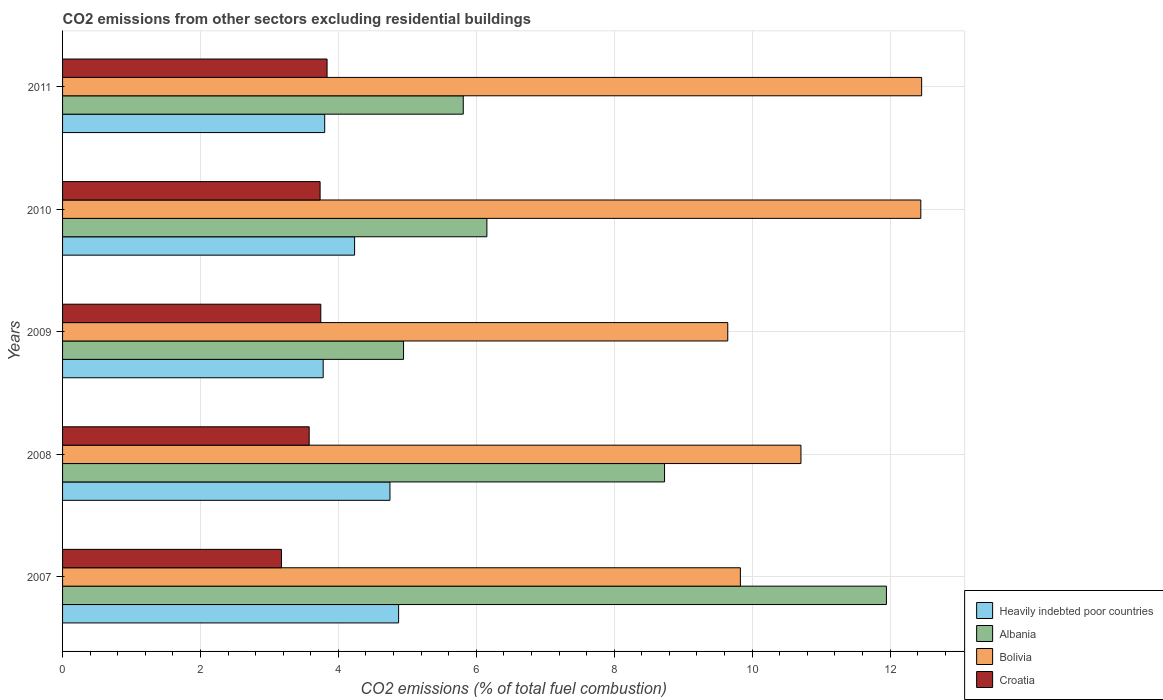How many different coloured bars are there?
Provide a short and direct response. 4. How many groups of bars are there?
Your answer should be very brief. 5. Are the number of bars on each tick of the Y-axis equal?
Ensure brevity in your answer.  Yes. How many bars are there on the 1st tick from the bottom?
Give a very brief answer. 4. What is the label of the 3rd group of bars from the top?
Make the answer very short. 2009. In how many cases, is the number of bars for a given year not equal to the number of legend labels?
Give a very brief answer. 0. What is the total CO2 emitted in Bolivia in 2007?
Make the answer very short. 9.83. Across all years, what is the maximum total CO2 emitted in Bolivia?
Your response must be concise. 12.46. Across all years, what is the minimum total CO2 emitted in Heavily indebted poor countries?
Provide a short and direct response. 3.78. In which year was the total CO2 emitted in Croatia maximum?
Your answer should be very brief. 2011. In which year was the total CO2 emitted in Croatia minimum?
Ensure brevity in your answer.  2007. What is the total total CO2 emitted in Bolivia in the graph?
Give a very brief answer. 55.09. What is the difference between the total CO2 emitted in Albania in 2007 and that in 2008?
Your answer should be very brief. 3.22. What is the difference between the total CO2 emitted in Bolivia in 2010 and the total CO2 emitted in Heavily indebted poor countries in 2008?
Make the answer very short. 7.7. What is the average total CO2 emitted in Croatia per year?
Your answer should be very brief. 3.61. In the year 2007, what is the difference between the total CO2 emitted in Albania and total CO2 emitted in Bolivia?
Your answer should be compact. 2.12. What is the ratio of the total CO2 emitted in Heavily indebted poor countries in 2010 to that in 2011?
Your answer should be compact. 1.11. Is the total CO2 emitted in Heavily indebted poor countries in 2008 less than that in 2011?
Keep it short and to the point. No. What is the difference between the highest and the second highest total CO2 emitted in Albania?
Your response must be concise. 3.22. What is the difference between the highest and the lowest total CO2 emitted in Croatia?
Your response must be concise. 0.66. Is the sum of the total CO2 emitted in Albania in 2008 and 2009 greater than the maximum total CO2 emitted in Croatia across all years?
Ensure brevity in your answer.  Yes. Is it the case that in every year, the sum of the total CO2 emitted in Albania and total CO2 emitted in Croatia is greater than the sum of total CO2 emitted in Bolivia and total CO2 emitted in Heavily indebted poor countries?
Make the answer very short. No. What does the 1st bar from the top in 2008 represents?
Provide a short and direct response. Croatia. What does the 4th bar from the bottom in 2010 represents?
Keep it short and to the point. Croatia. Does the graph contain grids?
Keep it short and to the point. Yes. How many legend labels are there?
Provide a succinct answer. 4. How are the legend labels stacked?
Give a very brief answer. Vertical. What is the title of the graph?
Give a very brief answer. CO2 emissions from other sectors excluding residential buildings. What is the label or title of the X-axis?
Ensure brevity in your answer.  CO2 emissions (% of total fuel combustion). What is the CO2 emissions (% of total fuel combustion) in Heavily indebted poor countries in 2007?
Offer a terse response. 4.87. What is the CO2 emissions (% of total fuel combustion) of Albania in 2007?
Make the answer very short. 11.95. What is the CO2 emissions (% of total fuel combustion) of Bolivia in 2007?
Keep it short and to the point. 9.83. What is the CO2 emissions (% of total fuel combustion) of Croatia in 2007?
Your answer should be compact. 3.17. What is the CO2 emissions (% of total fuel combustion) of Heavily indebted poor countries in 2008?
Offer a very short reply. 4.75. What is the CO2 emissions (% of total fuel combustion) in Albania in 2008?
Make the answer very short. 8.73. What is the CO2 emissions (% of total fuel combustion) of Bolivia in 2008?
Your answer should be very brief. 10.71. What is the CO2 emissions (% of total fuel combustion) in Croatia in 2008?
Offer a very short reply. 3.58. What is the CO2 emissions (% of total fuel combustion) in Heavily indebted poor countries in 2009?
Offer a very short reply. 3.78. What is the CO2 emissions (% of total fuel combustion) of Albania in 2009?
Provide a short and direct response. 4.95. What is the CO2 emissions (% of total fuel combustion) in Bolivia in 2009?
Offer a terse response. 9.65. What is the CO2 emissions (% of total fuel combustion) of Croatia in 2009?
Give a very brief answer. 3.74. What is the CO2 emissions (% of total fuel combustion) of Heavily indebted poor countries in 2010?
Give a very brief answer. 4.24. What is the CO2 emissions (% of total fuel combustion) in Albania in 2010?
Keep it short and to the point. 6.15. What is the CO2 emissions (% of total fuel combustion) in Bolivia in 2010?
Provide a short and direct response. 12.45. What is the CO2 emissions (% of total fuel combustion) of Croatia in 2010?
Give a very brief answer. 3.73. What is the CO2 emissions (% of total fuel combustion) of Heavily indebted poor countries in 2011?
Make the answer very short. 3.8. What is the CO2 emissions (% of total fuel combustion) of Albania in 2011?
Ensure brevity in your answer.  5.81. What is the CO2 emissions (% of total fuel combustion) in Bolivia in 2011?
Provide a short and direct response. 12.46. What is the CO2 emissions (% of total fuel combustion) of Croatia in 2011?
Keep it short and to the point. 3.84. Across all years, what is the maximum CO2 emissions (% of total fuel combustion) in Heavily indebted poor countries?
Make the answer very short. 4.87. Across all years, what is the maximum CO2 emissions (% of total fuel combustion) in Albania?
Your answer should be very brief. 11.95. Across all years, what is the maximum CO2 emissions (% of total fuel combustion) in Bolivia?
Your answer should be compact. 12.46. Across all years, what is the maximum CO2 emissions (% of total fuel combustion) in Croatia?
Offer a terse response. 3.84. Across all years, what is the minimum CO2 emissions (% of total fuel combustion) in Heavily indebted poor countries?
Your response must be concise. 3.78. Across all years, what is the minimum CO2 emissions (% of total fuel combustion) of Albania?
Offer a very short reply. 4.95. Across all years, what is the minimum CO2 emissions (% of total fuel combustion) in Bolivia?
Give a very brief answer. 9.65. Across all years, what is the minimum CO2 emissions (% of total fuel combustion) in Croatia?
Give a very brief answer. 3.17. What is the total CO2 emissions (% of total fuel combustion) of Heavily indebted poor countries in the graph?
Offer a terse response. 21.44. What is the total CO2 emissions (% of total fuel combustion) in Albania in the graph?
Your response must be concise. 37.59. What is the total CO2 emissions (% of total fuel combustion) of Bolivia in the graph?
Offer a very short reply. 55.09. What is the total CO2 emissions (% of total fuel combustion) in Croatia in the graph?
Make the answer very short. 18.07. What is the difference between the CO2 emissions (% of total fuel combustion) in Heavily indebted poor countries in 2007 and that in 2008?
Ensure brevity in your answer.  0.13. What is the difference between the CO2 emissions (% of total fuel combustion) of Albania in 2007 and that in 2008?
Provide a succinct answer. 3.22. What is the difference between the CO2 emissions (% of total fuel combustion) in Bolivia in 2007 and that in 2008?
Offer a very short reply. -0.88. What is the difference between the CO2 emissions (% of total fuel combustion) of Croatia in 2007 and that in 2008?
Offer a very short reply. -0.4. What is the difference between the CO2 emissions (% of total fuel combustion) in Heavily indebted poor countries in 2007 and that in 2009?
Offer a very short reply. 1.09. What is the difference between the CO2 emissions (% of total fuel combustion) of Albania in 2007 and that in 2009?
Ensure brevity in your answer.  7. What is the difference between the CO2 emissions (% of total fuel combustion) of Bolivia in 2007 and that in 2009?
Your answer should be compact. 0.18. What is the difference between the CO2 emissions (% of total fuel combustion) of Croatia in 2007 and that in 2009?
Your answer should be compact. -0.57. What is the difference between the CO2 emissions (% of total fuel combustion) in Heavily indebted poor countries in 2007 and that in 2010?
Make the answer very short. 0.64. What is the difference between the CO2 emissions (% of total fuel combustion) in Albania in 2007 and that in 2010?
Your answer should be very brief. 5.79. What is the difference between the CO2 emissions (% of total fuel combustion) of Bolivia in 2007 and that in 2010?
Give a very brief answer. -2.62. What is the difference between the CO2 emissions (% of total fuel combustion) in Croatia in 2007 and that in 2010?
Your response must be concise. -0.56. What is the difference between the CO2 emissions (% of total fuel combustion) in Heavily indebted poor countries in 2007 and that in 2011?
Provide a short and direct response. 1.07. What is the difference between the CO2 emissions (% of total fuel combustion) in Albania in 2007 and that in 2011?
Offer a very short reply. 6.14. What is the difference between the CO2 emissions (% of total fuel combustion) of Bolivia in 2007 and that in 2011?
Offer a terse response. -2.63. What is the difference between the CO2 emissions (% of total fuel combustion) in Croatia in 2007 and that in 2011?
Make the answer very short. -0.66. What is the difference between the CO2 emissions (% of total fuel combustion) of Heavily indebted poor countries in 2008 and that in 2009?
Your answer should be very brief. 0.97. What is the difference between the CO2 emissions (% of total fuel combustion) in Albania in 2008 and that in 2009?
Offer a terse response. 3.79. What is the difference between the CO2 emissions (% of total fuel combustion) of Bolivia in 2008 and that in 2009?
Keep it short and to the point. 1.06. What is the difference between the CO2 emissions (% of total fuel combustion) in Croatia in 2008 and that in 2009?
Offer a terse response. -0.17. What is the difference between the CO2 emissions (% of total fuel combustion) in Heavily indebted poor countries in 2008 and that in 2010?
Your answer should be very brief. 0.51. What is the difference between the CO2 emissions (% of total fuel combustion) in Albania in 2008 and that in 2010?
Ensure brevity in your answer.  2.58. What is the difference between the CO2 emissions (% of total fuel combustion) of Bolivia in 2008 and that in 2010?
Your answer should be very brief. -1.74. What is the difference between the CO2 emissions (% of total fuel combustion) in Croatia in 2008 and that in 2010?
Provide a short and direct response. -0.16. What is the difference between the CO2 emissions (% of total fuel combustion) in Heavily indebted poor countries in 2008 and that in 2011?
Offer a very short reply. 0.95. What is the difference between the CO2 emissions (% of total fuel combustion) in Albania in 2008 and that in 2011?
Your answer should be very brief. 2.92. What is the difference between the CO2 emissions (% of total fuel combustion) of Bolivia in 2008 and that in 2011?
Make the answer very short. -1.75. What is the difference between the CO2 emissions (% of total fuel combustion) of Croatia in 2008 and that in 2011?
Offer a very short reply. -0.26. What is the difference between the CO2 emissions (% of total fuel combustion) in Heavily indebted poor countries in 2009 and that in 2010?
Provide a succinct answer. -0.46. What is the difference between the CO2 emissions (% of total fuel combustion) of Albania in 2009 and that in 2010?
Keep it short and to the point. -1.21. What is the difference between the CO2 emissions (% of total fuel combustion) of Bolivia in 2009 and that in 2010?
Your answer should be compact. -2.8. What is the difference between the CO2 emissions (% of total fuel combustion) in Croatia in 2009 and that in 2010?
Your response must be concise. 0.01. What is the difference between the CO2 emissions (% of total fuel combustion) of Heavily indebted poor countries in 2009 and that in 2011?
Your answer should be very brief. -0.02. What is the difference between the CO2 emissions (% of total fuel combustion) in Albania in 2009 and that in 2011?
Give a very brief answer. -0.87. What is the difference between the CO2 emissions (% of total fuel combustion) in Bolivia in 2009 and that in 2011?
Provide a short and direct response. -2.81. What is the difference between the CO2 emissions (% of total fuel combustion) in Croatia in 2009 and that in 2011?
Make the answer very short. -0.09. What is the difference between the CO2 emissions (% of total fuel combustion) of Heavily indebted poor countries in 2010 and that in 2011?
Your response must be concise. 0.43. What is the difference between the CO2 emissions (% of total fuel combustion) of Albania in 2010 and that in 2011?
Make the answer very short. 0.34. What is the difference between the CO2 emissions (% of total fuel combustion) in Bolivia in 2010 and that in 2011?
Your answer should be very brief. -0.01. What is the difference between the CO2 emissions (% of total fuel combustion) in Croatia in 2010 and that in 2011?
Keep it short and to the point. -0.1. What is the difference between the CO2 emissions (% of total fuel combustion) in Heavily indebted poor countries in 2007 and the CO2 emissions (% of total fuel combustion) in Albania in 2008?
Keep it short and to the point. -3.86. What is the difference between the CO2 emissions (% of total fuel combustion) in Heavily indebted poor countries in 2007 and the CO2 emissions (% of total fuel combustion) in Bolivia in 2008?
Ensure brevity in your answer.  -5.83. What is the difference between the CO2 emissions (% of total fuel combustion) of Heavily indebted poor countries in 2007 and the CO2 emissions (% of total fuel combustion) of Croatia in 2008?
Offer a terse response. 1.3. What is the difference between the CO2 emissions (% of total fuel combustion) in Albania in 2007 and the CO2 emissions (% of total fuel combustion) in Bolivia in 2008?
Ensure brevity in your answer.  1.24. What is the difference between the CO2 emissions (% of total fuel combustion) in Albania in 2007 and the CO2 emissions (% of total fuel combustion) in Croatia in 2008?
Provide a succinct answer. 8.37. What is the difference between the CO2 emissions (% of total fuel combustion) of Bolivia in 2007 and the CO2 emissions (% of total fuel combustion) of Croatia in 2008?
Keep it short and to the point. 6.25. What is the difference between the CO2 emissions (% of total fuel combustion) in Heavily indebted poor countries in 2007 and the CO2 emissions (% of total fuel combustion) in Albania in 2009?
Provide a succinct answer. -0.07. What is the difference between the CO2 emissions (% of total fuel combustion) of Heavily indebted poor countries in 2007 and the CO2 emissions (% of total fuel combustion) of Bolivia in 2009?
Offer a terse response. -4.77. What is the difference between the CO2 emissions (% of total fuel combustion) in Heavily indebted poor countries in 2007 and the CO2 emissions (% of total fuel combustion) in Croatia in 2009?
Offer a very short reply. 1.13. What is the difference between the CO2 emissions (% of total fuel combustion) in Albania in 2007 and the CO2 emissions (% of total fuel combustion) in Bolivia in 2009?
Your answer should be very brief. 2.3. What is the difference between the CO2 emissions (% of total fuel combustion) in Albania in 2007 and the CO2 emissions (% of total fuel combustion) in Croatia in 2009?
Give a very brief answer. 8.2. What is the difference between the CO2 emissions (% of total fuel combustion) of Bolivia in 2007 and the CO2 emissions (% of total fuel combustion) of Croatia in 2009?
Provide a succinct answer. 6.09. What is the difference between the CO2 emissions (% of total fuel combustion) in Heavily indebted poor countries in 2007 and the CO2 emissions (% of total fuel combustion) in Albania in 2010?
Provide a succinct answer. -1.28. What is the difference between the CO2 emissions (% of total fuel combustion) in Heavily indebted poor countries in 2007 and the CO2 emissions (% of total fuel combustion) in Bolivia in 2010?
Your response must be concise. -7.57. What is the difference between the CO2 emissions (% of total fuel combustion) in Heavily indebted poor countries in 2007 and the CO2 emissions (% of total fuel combustion) in Croatia in 2010?
Give a very brief answer. 1.14. What is the difference between the CO2 emissions (% of total fuel combustion) of Albania in 2007 and the CO2 emissions (% of total fuel combustion) of Bolivia in 2010?
Give a very brief answer. -0.5. What is the difference between the CO2 emissions (% of total fuel combustion) of Albania in 2007 and the CO2 emissions (% of total fuel combustion) of Croatia in 2010?
Give a very brief answer. 8.21. What is the difference between the CO2 emissions (% of total fuel combustion) in Bolivia in 2007 and the CO2 emissions (% of total fuel combustion) in Croatia in 2010?
Provide a short and direct response. 6.1. What is the difference between the CO2 emissions (% of total fuel combustion) of Heavily indebted poor countries in 2007 and the CO2 emissions (% of total fuel combustion) of Albania in 2011?
Your answer should be very brief. -0.94. What is the difference between the CO2 emissions (% of total fuel combustion) of Heavily indebted poor countries in 2007 and the CO2 emissions (% of total fuel combustion) of Bolivia in 2011?
Offer a very short reply. -7.59. What is the difference between the CO2 emissions (% of total fuel combustion) of Heavily indebted poor countries in 2007 and the CO2 emissions (% of total fuel combustion) of Croatia in 2011?
Offer a terse response. 1.04. What is the difference between the CO2 emissions (% of total fuel combustion) of Albania in 2007 and the CO2 emissions (% of total fuel combustion) of Bolivia in 2011?
Your answer should be compact. -0.51. What is the difference between the CO2 emissions (% of total fuel combustion) of Albania in 2007 and the CO2 emissions (% of total fuel combustion) of Croatia in 2011?
Ensure brevity in your answer.  8.11. What is the difference between the CO2 emissions (% of total fuel combustion) in Bolivia in 2007 and the CO2 emissions (% of total fuel combustion) in Croatia in 2011?
Your answer should be very brief. 5.99. What is the difference between the CO2 emissions (% of total fuel combustion) in Heavily indebted poor countries in 2008 and the CO2 emissions (% of total fuel combustion) in Albania in 2009?
Keep it short and to the point. -0.2. What is the difference between the CO2 emissions (% of total fuel combustion) of Heavily indebted poor countries in 2008 and the CO2 emissions (% of total fuel combustion) of Bolivia in 2009?
Provide a short and direct response. -4.9. What is the difference between the CO2 emissions (% of total fuel combustion) in Albania in 2008 and the CO2 emissions (% of total fuel combustion) in Bolivia in 2009?
Your answer should be compact. -0.92. What is the difference between the CO2 emissions (% of total fuel combustion) of Albania in 2008 and the CO2 emissions (% of total fuel combustion) of Croatia in 2009?
Make the answer very short. 4.99. What is the difference between the CO2 emissions (% of total fuel combustion) in Bolivia in 2008 and the CO2 emissions (% of total fuel combustion) in Croatia in 2009?
Provide a short and direct response. 6.96. What is the difference between the CO2 emissions (% of total fuel combustion) of Heavily indebted poor countries in 2008 and the CO2 emissions (% of total fuel combustion) of Albania in 2010?
Offer a very short reply. -1.41. What is the difference between the CO2 emissions (% of total fuel combustion) in Heavily indebted poor countries in 2008 and the CO2 emissions (% of total fuel combustion) in Bolivia in 2010?
Provide a short and direct response. -7.7. What is the difference between the CO2 emissions (% of total fuel combustion) in Albania in 2008 and the CO2 emissions (% of total fuel combustion) in Bolivia in 2010?
Offer a terse response. -3.72. What is the difference between the CO2 emissions (% of total fuel combustion) in Albania in 2008 and the CO2 emissions (% of total fuel combustion) in Croatia in 2010?
Ensure brevity in your answer.  5. What is the difference between the CO2 emissions (% of total fuel combustion) of Bolivia in 2008 and the CO2 emissions (% of total fuel combustion) of Croatia in 2010?
Your answer should be compact. 6.97. What is the difference between the CO2 emissions (% of total fuel combustion) in Heavily indebted poor countries in 2008 and the CO2 emissions (% of total fuel combustion) in Albania in 2011?
Keep it short and to the point. -1.06. What is the difference between the CO2 emissions (% of total fuel combustion) of Heavily indebted poor countries in 2008 and the CO2 emissions (% of total fuel combustion) of Bolivia in 2011?
Provide a succinct answer. -7.71. What is the difference between the CO2 emissions (% of total fuel combustion) in Heavily indebted poor countries in 2008 and the CO2 emissions (% of total fuel combustion) in Croatia in 2011?
Your answer should be compact. 0.91. What is the difference between the CO2 emissions (% of total fuel combustion) of Albania in 2008 and the CO2 emissions (% of total fuel combustion) of Bolivia in 2011?
Keep it short and to the point. -3.73. What is the difference between the CO2 emissions (% of total fuel combustion) of Albania in 2008 and the CO2 emissions (% of total fuel combustion) of Croatia in 2011?
Offer a terse response. 4.89. What is the difference between the CO2 emissions (% of total fuel combustion) in Bolivia in 2008 and the CO2 emissions (% of total fuel combustion) in Croatia in 2011?
Offer a terse response. 6.87. What is the difference between the CO2 emissions (% of total fuel combustion) in Heavily indebted poor countries in 2009 and the CO2 emissions (% of total fuel combustion) in Albania in 2010?
Ensure brevity in your answer.  -2.37. What is the difference between the CO2 emissions (% of total fuel combustion) in Heavily indebted poor countries in 2009 and the CO2 emissions (% of total fuel combustion) in Bolivia in 2010?
Provide a short and direct response. -8.67. What is the difference between the CO2 emissions (% of total fuel combustion) of Heavily indebted poor countries in 2009 and the CO2 emissions (% of total fuel combustion) of Croatia in 2010?
Your response must be concise. 0.04. What is the difference between the CO2 emissions (% of total fuel combustion) in Albania in 2009 and the CO2 emissions (% of total fuel combustion) in Bolivia in 2010?
Offer a very short reply. -7.5. What is the difference between the CO2 emissions (% of total fuel combustion) in Albania in 2009 and the CO2 emissions (% of total fuel combustion) in Croatia in 2010?
Make the answer very short. 1.21. What is the difference between the CO2 emissions (% of total fuel combustion) of Bolivia in 2009 and the CO2 emissions (% of total fuel combustion) of Croatia in 2010?
Offer a terse response. 5.91. What is the difference between the CO2 emissions (% of total fuel combustion) of Heavily indebted poor countries in 2009 and the CO2 emissions (% of total fuel combustion) of Albania in 2011?
Offer a very short reply. -2.03. What is the difference between the CO2 emissions (% of total fuel combustion) of Heavily indebted poor countries in 2009 and the CO2 emissions (% of total fuel combustion) of Bolivia in 2011?
Provide a succinct answer. -8.68. What is the difference between the CO2 emissions (% of total fuel combustion) in Heavily indebted poor countries in 2009 and the CO2 emissions (% of total fuel combustion) in Croatia in 2011?
Provide a short and direct response. -0.06. What is the difference between the CO2 emissions (% of total fuel combustion) in Albania in 2009 and the CO2 emissions (% of total fuel combustion) in Bolivia in 2011?
Keep it short and to the point. -7.51. What is the difference between the CO2 emissions (% of total fuel combustion) in Albania in 2009 and the CO2 emissions (% of total fuel combustion) in Croatia in 2011?
Give a very brief answer. 1.11. What is the difference between the CO2 emissions (% of total fuel combustion) in Bolivia in 2009 and the CO2 emissions (% of total fuel combustion) in Croatia in 2011?
Make the answer very short. 5.81. What is the difference between the CO2 emissions (% of total fuel combustion) of Heavily indebted poor countries in 2010 and the CO2 emissions (% of total fuel combustion) of Albania in 2011?
Keep it short and to the point. -1.58. What is the difference between the CO2 emissions (% of total fuel combustion) in Heavily indebted poor countries in 2010 and the CO2 emissions (% of total fuel combustion) in Bolivia in 2011?
Provide a succinct answer. -8.22. What is the difference between the CO2 emissions (% of total fuel combustion) of Heavily indebted poor countries in 2010 and the CO2 emissions (% of total fuel combustion) of Croatia in 2011?
Offer a very short reply. 0.4. What is the difference between the CO2 emissions (% of total fuel combustion) in Albania in 2010 and the CO2 emissions (% of total fuel combustion) in Bolivia in 2011?
Make the answer very short. -6.31. What is the difference between the CO2 emissions (% of total fuel combustion) of Albania in 2010 and the CO2 emissions (% of total fuel combustion) of Croatia in 2011?
Provide a succinct answer. 2.32. What is the difference between the CO2 emissions (% of total fuel combustion) in Bolivia in 2010 and the CO2 emissions (% of total fuel combustion) in Croatia in 2011?
Make the answer very short. 8.61. What is the average CO2 emissions (% of total fuel combustion) of Heavily indebted poor countries per year?
Offer a terse response. 4.29. What is the average CO2 emissions (% of total fuel combustion) in Albania per year?
Provide a short and direct response. 7.52. What is the average CO2 emissions (% of total fuel combustion) in Bolivia per year?
Keep it short and to the point. 11.02. What is the average CO2 emissions (% of total fuel combustion) in Croatia per year?
Give a very brief answer. 3.61. In the year 2007, what is the difference between the CO2 emissions (% of total fuel combustion) of Heavily indebted poor countries and CO2 emissions (% of total fuel combustion) of Albania?
Give a very brief answer. -7.07. In the year 2007, what is the difference between the CO2 emissions (% of total fuel combustion) in Heavily indebted poor countries and CO2 emissions (% of total fuel combustion) in Bolivia?
Your response must be concise. -4.96. In the year 2007, what is the difference between the CO2 emissions (% of total fuel combustion) in Heavily indebted poor countries and CO2 emissions (% of total fuel combustion) in Croatia?
Give a very brief answer. 1.7. In the year 2007, what is the difference between the CO2 emissions (% of total fuel combustion) of Albania and CO2 emissions (% of total fuel combustion) of Bolivia?
Your answer should be compact. 2.12. In the year 2007, what is the difference between the CO2 emissions (% of total fuel combustion) in Albania and CO2 emissions (% of total fuel combustion) in Croatia?
Keep it short and to the point. 8.77. In the year 2007, what is the difference between the CO2 emissions (% of total fuel combustion) in Bolivia and CO2 emissions (% of total fuel combustion) in Croatia?
Your response must be concise. 6.66. In the year 2008, what is the difference between the CO2 emissions (% of total fuel combustion) of Heavily indebted poor countries and CO2 emissions (% of total fuel combustion) of Albania?
Ensure brevity in your answer.  -3.98. In the year 2008, what is the difference between the CO2 emissions (% of total fuel combustion) in Heavily indebted poor countries and CO2 emissions (% of total fuel combustion) in Bolivia?
Give a very brief answer. -5.96. In the year 2008, what is the difference between the CO2 emissions (% of total fuel combustion) of Heavily indebted poor countries and CO2 emissions (% of total fuel combustion) of Croatia?
Provide a short and direct response. 1.17. In the year 2008, what is the difference between the CO2 emissions (% of total fuel combustion) of Albania and CO2 emissions (% of total fuel combustion) of Bolivia?
Your response must be concise. -1.98. In the year 2008, what is the difference between the CO2 emissions (% of total fuel combustion) in Albania and CO2 emissions (% of total fuel combustion) in Croatia?
Offer a terse response. 5.15. In the year 2008, what is the difference between the CO2 emissions (% of total fuel combustion) in Bolivia and CO2 emissions (% of total fuel combustion) in Croatia?
Make the answer very short. 7.13. In the year 2009, what is the difference between the CO2 emissions (% of total fuel combustion) in Heavily indebted poor countries and CO2 emissions (% of total fuel combustion) in Albania?
Make the answer very short. -1.17. In the year 2009, what is the difference between the CO2 emissions (% of total fuel combustion) in Heavily indebted poor countries and CO2 emissions (% of total fuel combustion) in Bolivia?
Offer a very short reply. -5.87. In the year 2009, what is the difference between the CO2 emissions (% of total fuel combustion) in Heavily indebted poor countries and CO2 emissions (% of total fuel combustion) in Croatia?
Give a very brief answer. 0.03. In the year 2009, what is the difference between the CO2 emissions (% of total fuel combustion) in Albania and CO2 emissions (% of total fuel combustion) in Bolivia?
Offer a terse response. -4.7. In the year 2009, what is the difference between the CO2 emissions (% of total fuel combustion) in Albania and CO2 emissions (% of total fuel combustion) in Croatia?
Make the answer very short. 1.2. In the year 2009, what is the difference between the CO2 emissions (% of total fuel combustion) of Bolivia and CO2 emissions (% of total fuel combustion) of Croatia?
Your answer should be very brief. 5.9. In the year 2010, what is the difference between the CO2 emissions (% of total fuel combustion) in Heavily indebted poor countries and CO2 emissions (% of total fuel combustion) in Albania?
Offer a very short reply. -1.92. In the year 2010, what is the difference between the CO2 emissions (% of total fuel combustion) in Heavily indebted poor countries and CO2 emissions (% of total fuel combustion) in Bolivia?
Offer a very short reply. -8.21. In the year 2010, what is the difference between the CO2 emissions (% of total fuel combustion) of Heavily indebted poor countries and CO2 emissions (% of total fuel combustion) of Croatia?
Your answer should be very brief. 0.5. In the year 2010, what is the difference between the CO2 emissions (% of total fuel combustion) of Albania and CO2 emissions (% of total fuel combustion) of Bolivia?
Your answer should be compact. -6.29. In the year 2010, what is the difference between the CO2 emissions (% of total fuel combustion) in Albania and CO2 emissions (% of total fuel combustion) in Croatia?
Provide a succinct answer. 2.42. In the year 2010, what is the difference between the CO2 emissions (% of total fuel combustion) of Bolivia and CO2 emissions (% of total fuel combustion) of Croatia?
Make the answer very short. 8.71. In the year 2011, what is the difference between the CO2 emissions (% of total fuel combustion) of Heavily indebted poor countries and CO2 emissions (% of total fuel combustion) of Albania?
Keep it short and to the point. -2.01. In the year 2011, what is the difference between the CO2 emissions (% of total fuel combustion) in Heavily indebted poor countries and CO2 emissions (% of total fuel combustion) in Bolivia?
Provide a short and direct response. -8.66. In the year 2011, what is the difference between the CO2 emissions (% of total fuel combustion) of Heavily indebted poor countries and CO2 emissions (% of total fuel combustion) of Croatia?
Your answer should be very brief. -0.03. In the year 2011, what is the difference between the CO2 emissions (% of total fuel combustion) of Albania and CO2 emissions (% of total fuel combustion) of Bolivia?
Give a very brief answer. -6.65. In the year 2011, what is the difference between the CO2 emissions (% of total fuel combustion) of Albania and CO2 emissions (% of total fuel combustion) of Croatia?
Make the answer very short. 1.98. In the year 2011, what is the difference between the CO2 emissions (% of total fuel combustion) in Bolivia and CO2 emissions (% of total fuel combustion) in Croatia?
Provide a short and direct response. 8.62. What is the ratio of the CO2 emissions (% of total fuel combustion) in Heavily indebted poor countries in 2007 to that in 2008?
Your answer should be very brief. 1.03. What is the ratio of the CO2 emissions (% of total fuel combustion) of Albania in 2007 to that in 2008?
Provide a succinct answer. 1.37. What is the ratio of the CO2 emissions (% of total fuel combustion) in Bolivia in 2007 to that in 2008?
Make the answer very short. 0.92. What is the ratio of the CO2 emissions (% of total fuel combustion) of Croatia in 2007 to that in 2008?
Offer a very short reply. 0.89. What is the ratio of the CO2 emissions (% of total fuel combustion) in Heavily indebted poor countries in 2007 to that in 2009?
Give a very brief answer. 1.29. What is the ratio of the CO2 emissions (% of total fuel combustion) in Albania in 2007 to that in 2009?
Give a very brief answer. 2.42. What is the ratio of the CO2 emissions (% of total fuel combustion) of Bolivia in 2007 to that in 2009?
Ensure brevity in your answer.  1.02. What is the ratio of the CO2 emissions (% of total fuel combustion) in Croatia in 2007 to that in 2009?
Your answer should be very brief. 0.85. What is the ratio of the CO2 emissions (% of total fuel combustion) in Heavily indebted poor countries in 2007 to that in 2010?
Make the answer very short. 1.15. What is the ratio of the CO2 emissions (% of total fuel combustion) of Albania in 2007 to that in 2010?
Make the answer very short. 1.94. What is the ratio of the CO2 emissions (% of total fuel combustion) of Bolivia in 2007 to that in 2010?
Keep it short and to the point. 0.79. What is the ratio of the CO2 emissions (% of total fuel combustion) in Croatia in 2007 to that in 2010?
Provide a succinct answer. 0.85. What is the ratio of the CO2 emissions (% of total fuel combustion) in Heavily indebted poor countries in 2007 to that in 2011?
Offer a terse response. 1.28. What is the ratio of the CO2 emissions (% of total fuel combustion) in Albania in 2007 to that in 2011?
Make the answer very short. 2.06. What is the ratio of the CO2 emissions (% of total fuel combustion) of Bolivia in 2007 to that in 2011?
Ensure brevity in your answer.  0.79. What is the ratio of the CO2 emissions (% of total fuel combustion) in Croatia in 2007 to that in 2011?
Offer a terse response. 0.83. What is the ratio of the CO2 emissions (% of total fuel combustion) of Heavily indebted poor countries in 2008 to that in 2009?
Provide a short and direct response. 1.26. What is the ratio of the CO2 emissions (% of total fuel combustion) of Albania in 2008 to that in 2009?
Make the answer very short. 1.77. What is the ratio of the CO2 emissions (% of total fuel combustion) of Bolivia in 2008 to that in 2009?
Give a very brief answer. 1.11. What is the ratio of the CO2 emissions (% of total fuel combustion) in Croatia in 2008 to that in 2009?
Offer a very short reply. 0.95. What is the ratio of the CO2 emissions (% of total fuel combustion) in Heavily indebted poor countries in 2008 to that in 2010?
Offer a terse response. 1.12. What is the ratio of the CO2 emissions (% of total fuel combustion) in Albania in 2008 to that in 2010?
Your answer should be compact. 1.42. What is the ratio of the CO2 emissions (% of total fuel combustion) in Bolivia in 2008 to that in 2010?
Make the answer very short. 0.86. What is the ratio of the CO2 emissions (% of total fuel combustion) in Croatia in 2008 to that in 2010?
Ensure brevity in your answer.  0.96. What is the ratio of the CO2 emissions (% of total fuel combustion) in Heavily indebted poor countries in 2008 to that in 2011?
Your response must be concise. 1.25. What is the ratio of the CO2 emissions (% of total fuel combustion) of Albania in 2008 to that in 2011?
Provide a succinct answer. 1.5. What is the ratio of the CO2 emissions (% of total fuel combustion) of Bolivia in 2008 to that in 2011?
Provide a succinct answer. 0.86. What is the ratio of the CO2 emissions (% of total fuel combustion) in Croatia in 2008 to that in 2011?
Make the answer very short. 0.93. What is the ratio of the CO2 emissions (% of total fuel combustion) in Heavily indebted poor countries in 2009 to that in 2010?
Offer a very short reply. 0.89. What is the ratio of the CO2 emissions (% of total fuel combustion) of Albania in 2009 to that in 2010?
Keep it short and to the point. 0.8. What is the ratio of the CO2 emissions (% of total fuel combustion) in Bolivia in 2009 to that in 2010?
Keep it short and to the point. 0.78. What is the ratio of the CO2 emissions (% of total fuel combustion) in Croatia in 2009 to that in 2010?
Provide a succinct answer. 1. What is the ratio of the CO2 emissions (% of total fuel combustion) in Heavily indebted poor countries in 2009 to that in 2011?
Ensure brevity in your answer.  0.99. What is the ratio of the CO2 emissions (% of total fuel combustion) in Albania in 2009 to that in 2011?
Your response must be concise. 0.85. What is the ratio of the CO2 emissions (% of total fuel combustion) in Bolivia in 2009 to that in 2011?
Offer a very short reply. 0.77. What is the ratio of the CO2 emissions (% of total fuel combustion) of Croatia in 2009 to that in 2011?
Your answer should be compact. 0.98. What is the ratio of the CO2 emissions (% of total fuel combustion) in Heavily indebted poor countries in 2010 to that in 2011?
Offer a terse response. 1.11. What is the ratio of the CO2 emissions (% of total fuel combustion) of Albania in 2010 to that in 2011?
Provide a short and direct response. 1.06. What is the ratio of the CO2 emissions (% of total fuel combustion) in Bolivia in 2010 to that in 2011?
Offer a very short reply. 1. What is the ratio of the CO2 emissions (% of total fuel combustion) in Croatia in 2010 to that in 2011?
Your answer should be very brief. 0.97. What is the difference between the highest and the second highest CO2 emissions (% of total fuel combustion) of Heavily indebted poor countries?
Offer a very short reply. 0.13. What is the difference between the highest and the second highest CO2 emissions (% of total fuel combustion) of Albania?
Offer a terse response. 3.22. What is the difference between the highest and the second highest CO2 emissions (% of total fuel combustion) in Bolivia?
Your response must be concise. 0.01. What is the difference between the highest and the second highest CO2 emissions (% of total fuel combustion) of Croatia?
Provide a succinct answer. 0.09. What is the difference between the highest and the lowest CO2 emissions (% of total fuel combustion) of Heavily indebted poor countries?
Your response must be concise. 1.09. What is the difference between the highest and the lowest CO2 emissions (% of total fuel combustion) of Albania?
Your answer should be very brief. 7. What is the difference between the highest and the lowest CO2 emissions (% of total fuel combustion) of Bolivia?
Ensure brevity in your answer.  2.81. What is the difference between the highest and the lowest CO2 emissions (% of total fuel combustion) in Croatia?
Keep it short and to the point. 0.66. 